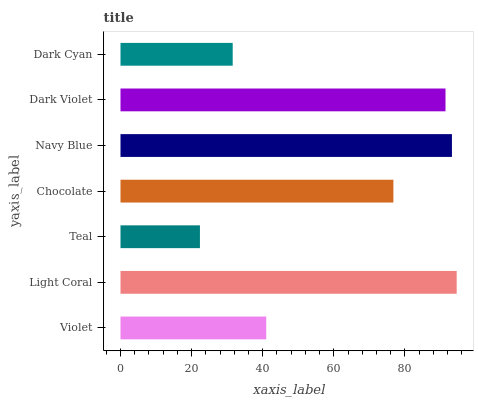Is Teal the minimum?
Answer yes or no. Yes. Is Light Coral the maximum?
Answer yes or no. Yes. Is Light Coral the minimum?
Answer yes or no. No. Is Teal the maximum?
Answer yes or no. No. Is Light Coral greater than Teal?
Answer yes or no. Yes. Is Teal less than Light Coral?
Answer yes or no. Yes. Is Teal greater than Light Coral?
Answer yes or no. No. Is Light Coral less than Teal?
Answer yes or no. No. Is Chocolate the high median?
Answer yes or no. Yes. Is Chocolate the low median?
Answer yes or no. Yes. Is Dark Cyan the high median?
Answer yes or no. No. Is Light Coral the low median?
Answer yes or no. No. 